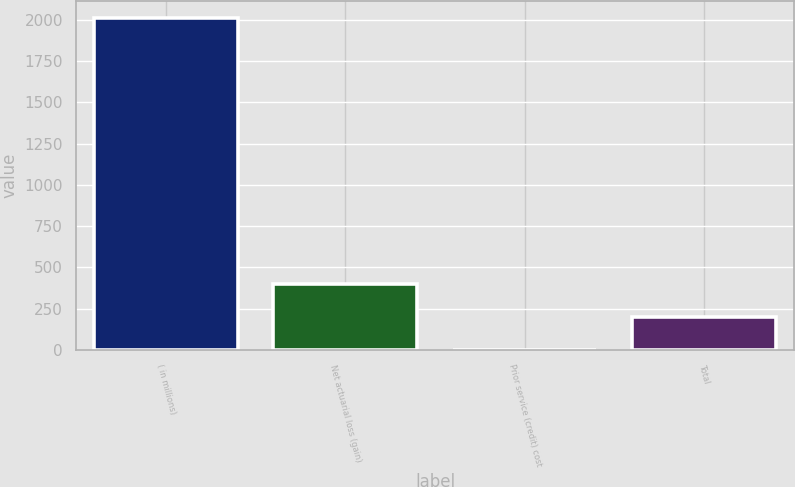Convert chart. <chart><loc_0><loc_0><loc_500><loc_500><bar_chart><fcel>( in millions)<fcel>Net actuarial loss (gain)<fcel>Prior service (credit) cost<fcel>Total<nl><fcel>2010<fcel>402.16<fcel>0.2<fcel>201.18<nl></chart> 